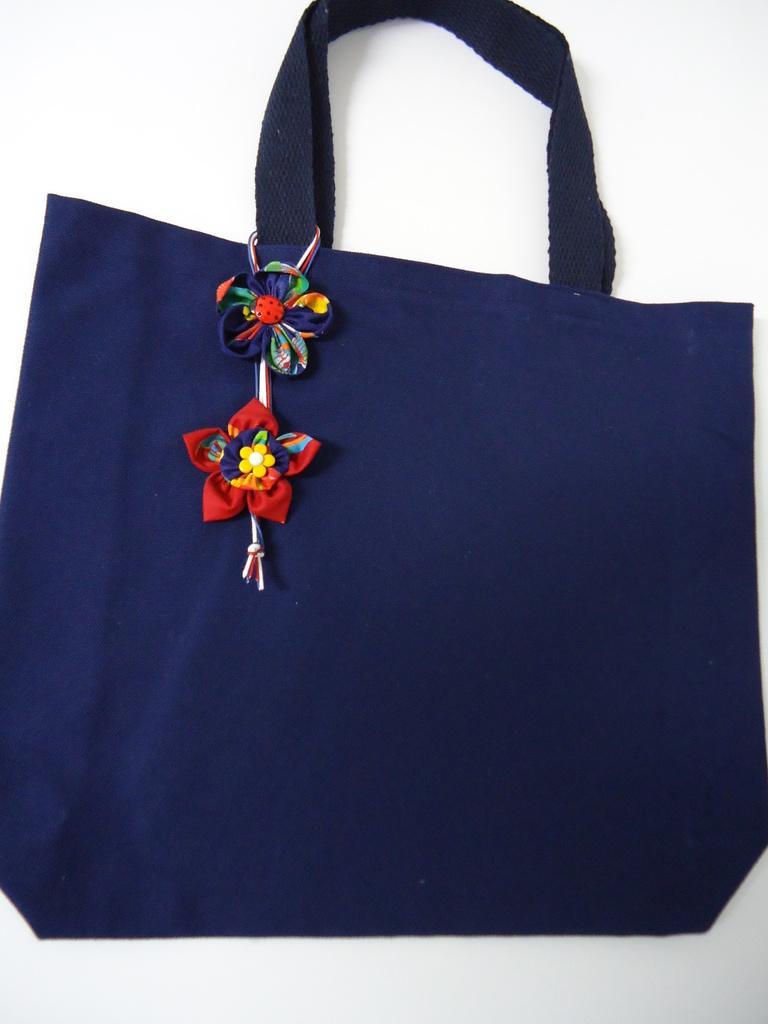Please provide a concise description of this image. In this image, There is a bag of blue color on that bag there are two flowers, That bag is hanging on the white color wall. 